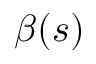Convert formula to latex. <formula><loc_0><loc_0><loc_500><loc_500>\beta ( s )</formula> 